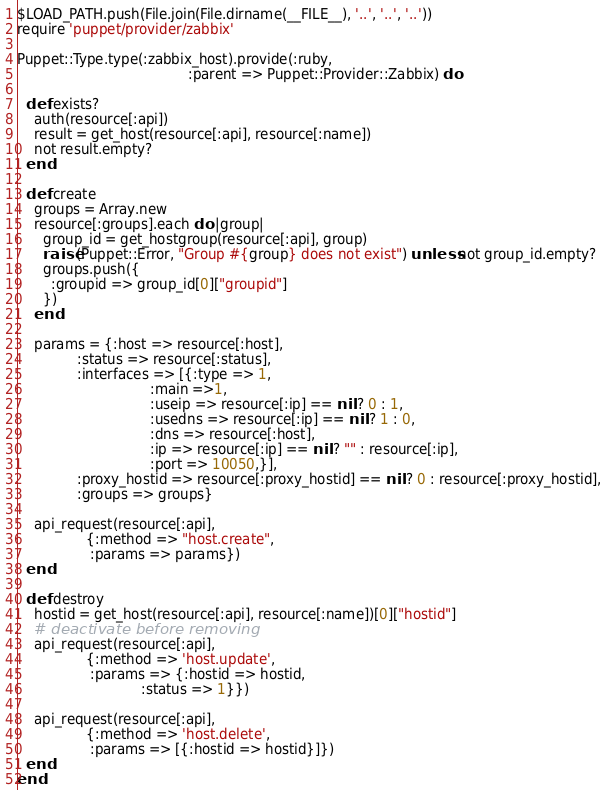<code> <loc_0><loc_0><loc_500><loc_500><_Ruby_>$LOAD_PATH.push(File.join(File.dirname(__FILE__), '..', '..', '..'))
require 'puppet/provider/zabbix'

Puppet::Type.type(:zabbix_host).provide(:ruby,
                                        :parent => Puppet::Provider::Zabbix) do

  def exists?
    auth(resource[:api])
    result = get_host(resource[:api], resource[:name])
    not result.empty?
  end

  def create
    groups = Array.new
    resource[:groups].each do |group|
      group_id = get_hostgroup(resource[:api], group)
      raise(Puppet::Error, "Group #{group} does not exist") unless not group_id.empty?
      groups.push({
        :groupid => group_id[0]["groupid"]
      })
    end

    params = {:host => resource[:host],
              :status => resource[:status],
              :interfaces => [{:type => 1,
                               :main =>1,
                               :useip => resource[:ip] == nil ? 0 : 1,
                               :usedns => resource[:ip] == nil ? 1 : 0,
                               :dns => resource[:host],
                               :ip => resource[:ip] == nil ? "" : resource[:ip],
                               :port => 10050,}],
              :proxy_hostid => resource[:proxy_hostid] == nil ? 0 : resource[:proxy_hostid],
              :groups => groups}

    api_request(resource[:api],
                {:method => "host.create",
                 :params => params})
  end

  def destroy
    hostid = get_host(resource[:api], resource[:name])[0]["hostid"]
    # deactivate before removing
    api_request(resource[:api],
                {:method => 'host.update',
                 :params => {:hostid => hostid,
                             :status => 1}})

    api_request(resource[:api],
                {:method => 'host.delete',
                 :params => [{:hostid => hostid}]})
  end
end
</code> 